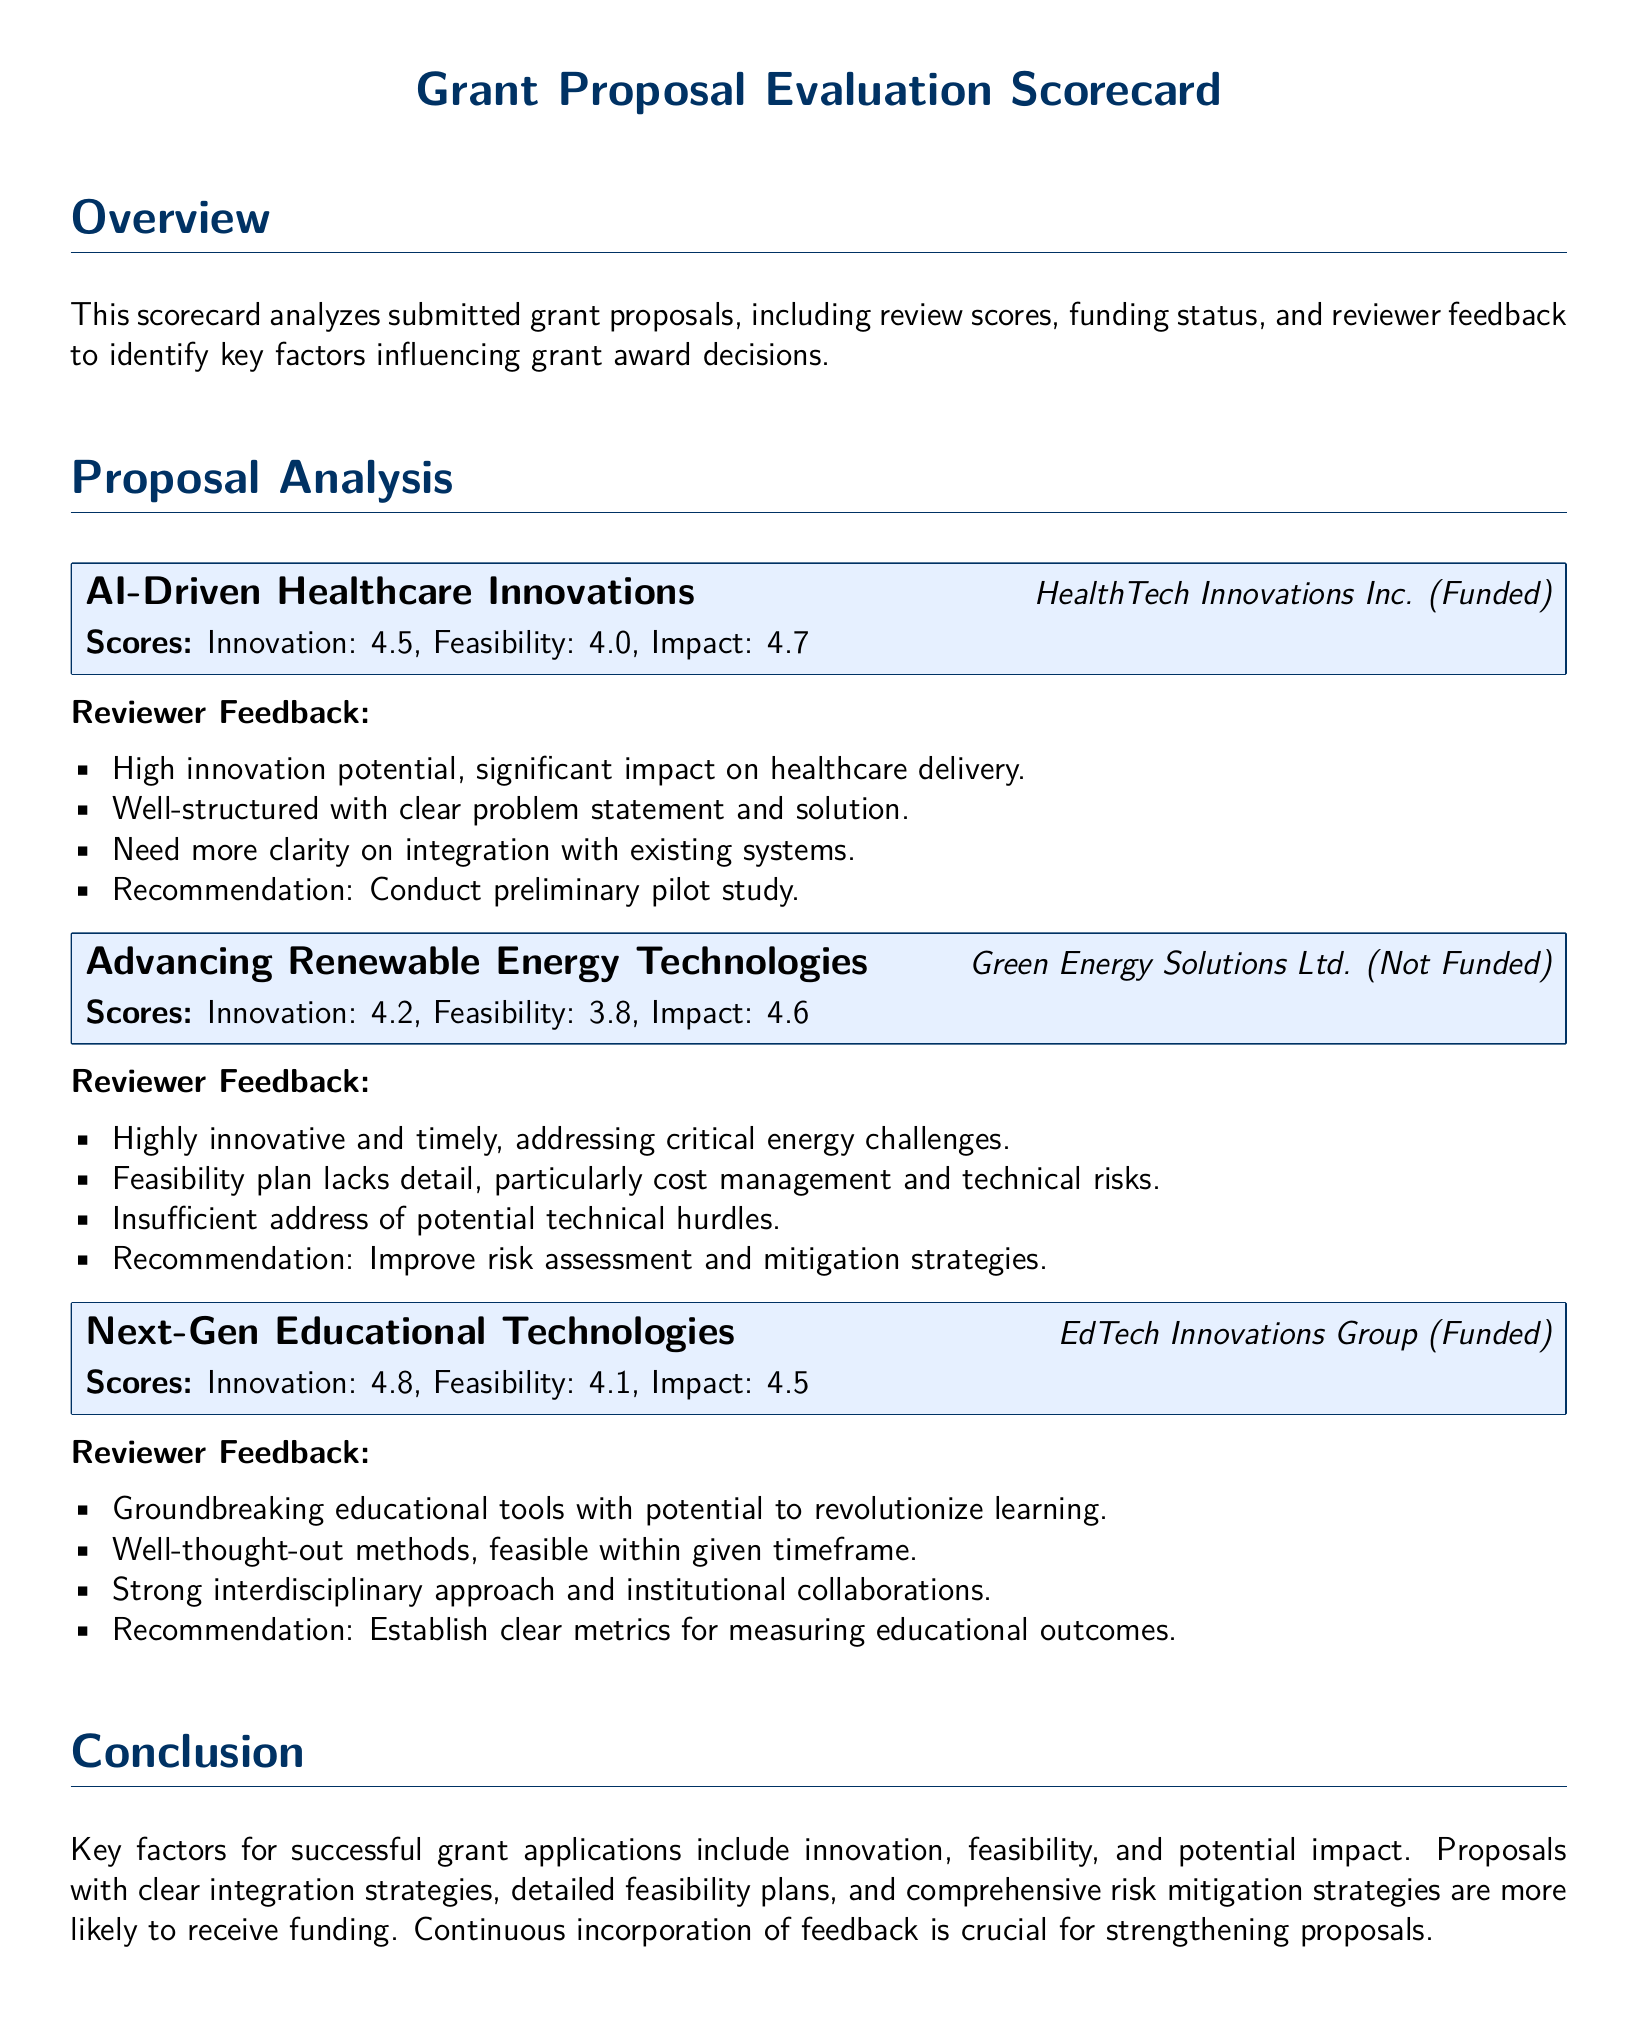What is the title of the scorecard? The title is prominently displayed at the top of the document and is "Grant Proposal Evaluation Scorecard."
Answer: Grant Proposal Evaluation Scorecard How many proposals are analyzed in the document? The document analyzes three proposals as indicated in the proposal analysis section.
Answer: 3 What organization submitted the proposal "Advancing Renewable Energy Technologies"? This information is found directly after the proposal title in the score entry for that proposal.
Answer: Green Energy Solutions Ltd What is the feasibility score of "Next-Gen Educational Technologies"? The score is listed directly beneath the proposal entry, specifically noted for feasibility.
Answer: 4.1 Which proposal received the highest innovation score? The comparison of innovation scores across proposals indicates the highest score.
Answer: Next-Gen Educational Technologies What key factor is identified for successful grant applications? This information is summarized in the conclusion section, highlighting important factors for success.
Answer: Innovation What suggestion was given for the "AI-Driven Healthcare Innovations"? The detailed feedback for this proposal lists reviewer recommendations.
Answer: Conduct preliminary pilot study Which proposal was funded? The funding status is noted next to each proposal title, indicating whether they were funded or not.
Answer: AI-Driven Healthcare Innovations, Next-Gen Educational Technologies What was a concern regarding the "Advancing Renewable Energy Technologies"? The reviewer feedback contains specific concerns about the proposal's details.
Answer: Feasibility plan lacks detail 